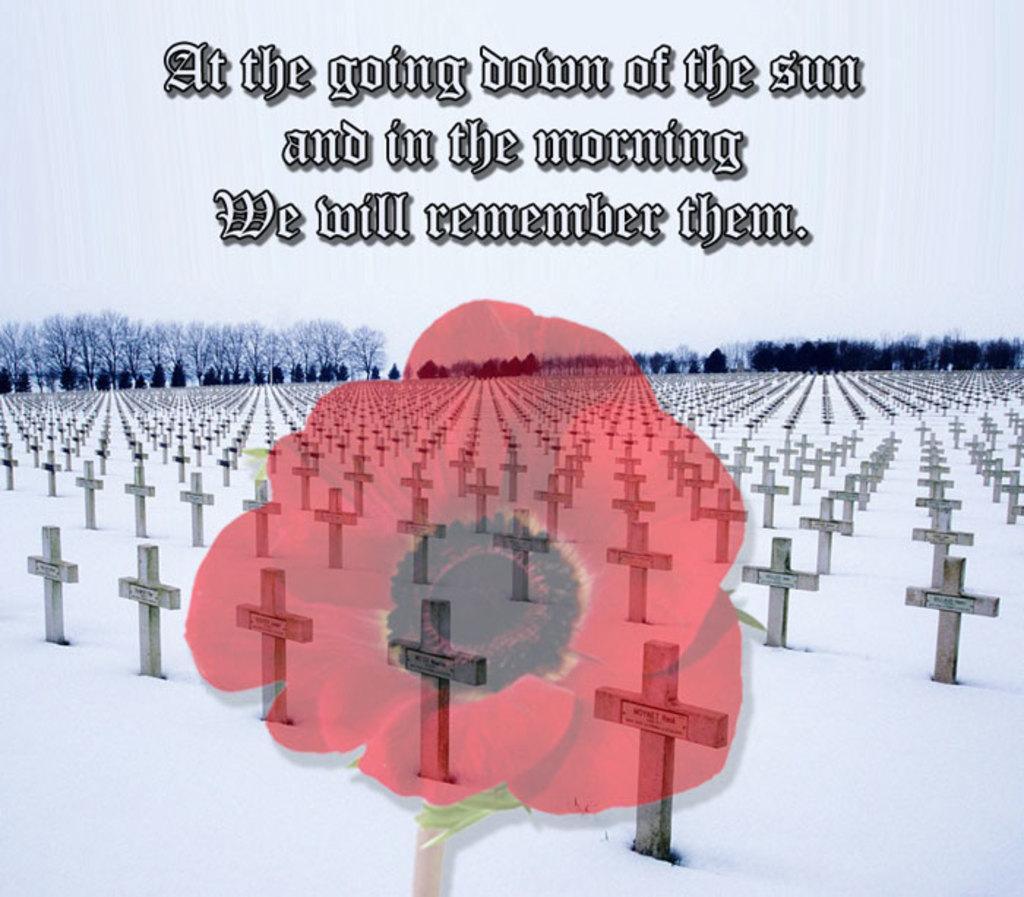How would you summarize this image in a sentence or two? It is a graphical image. In the image we can see a red color flower and there are some crosses and trees and there is a quotation. 